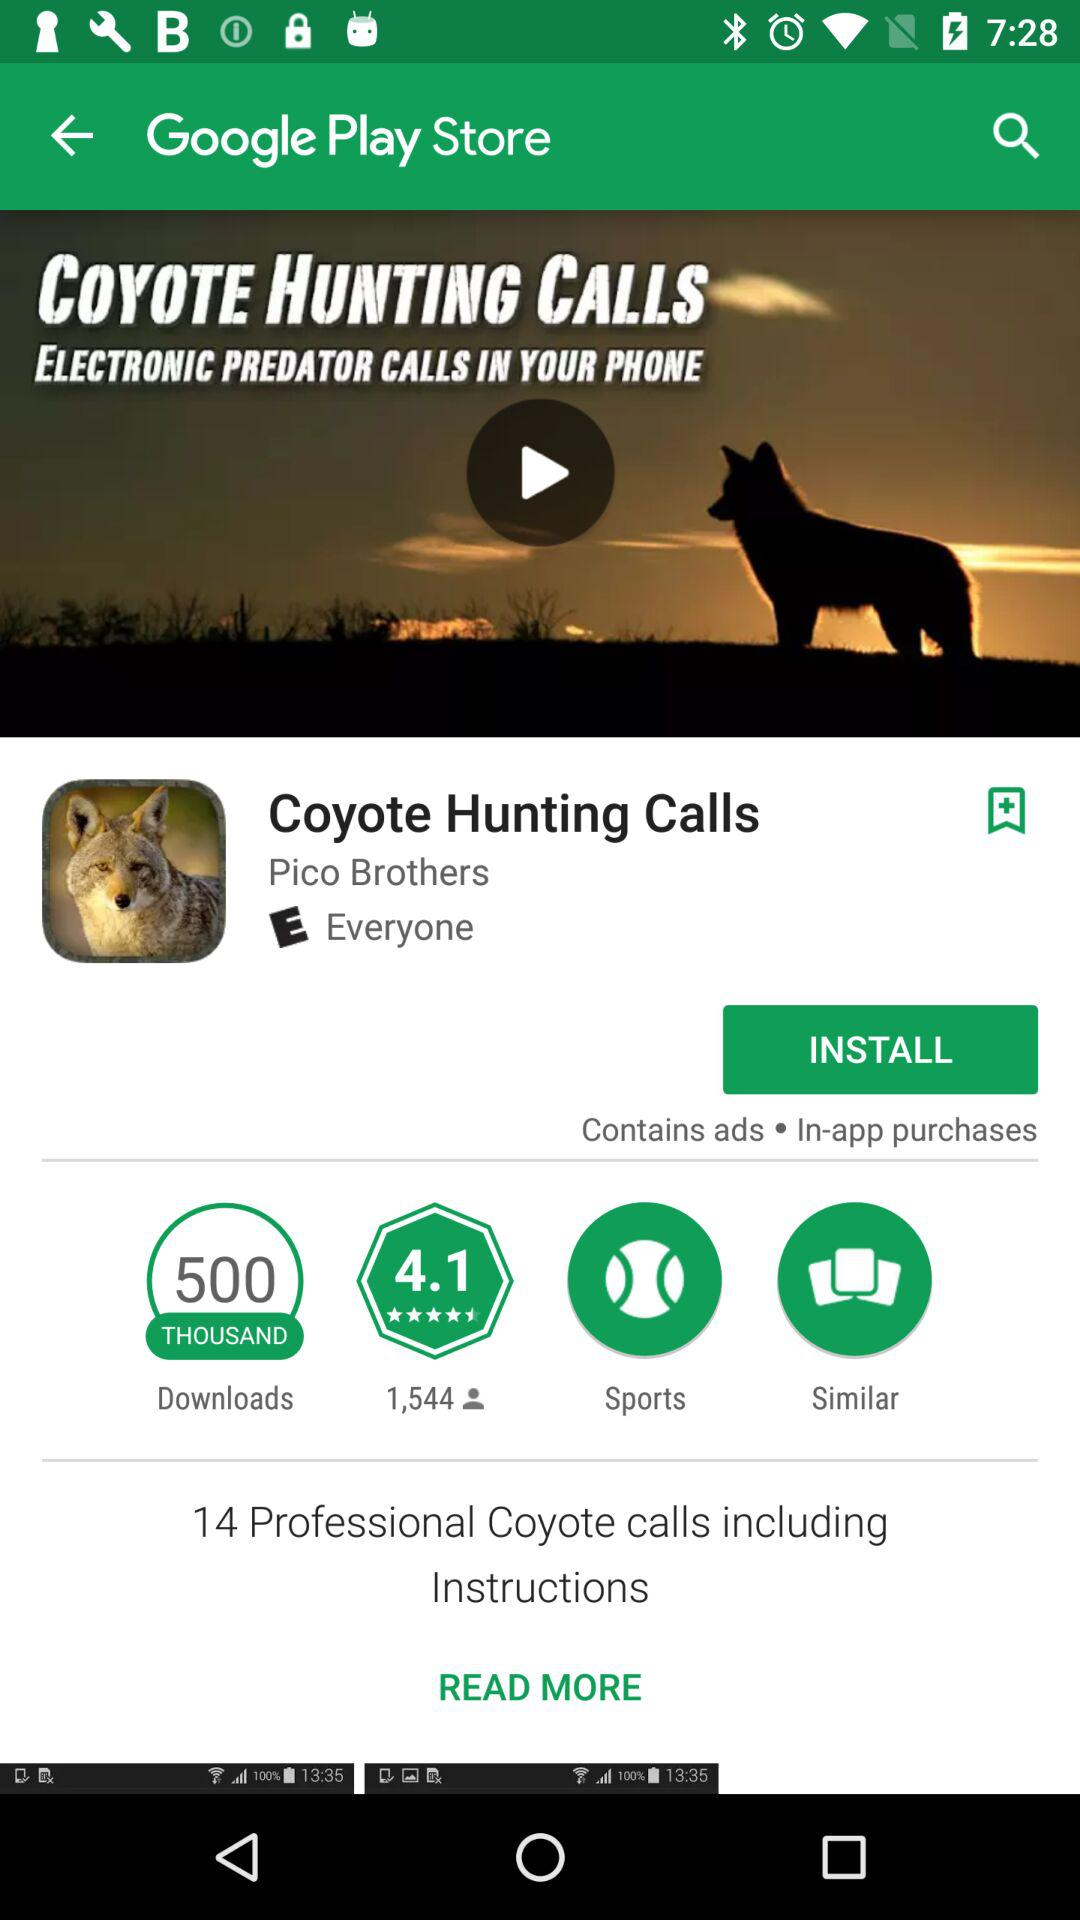What's the number of professional coyote calls including instructions? The number of professional coyote calls including instructions is 14. 